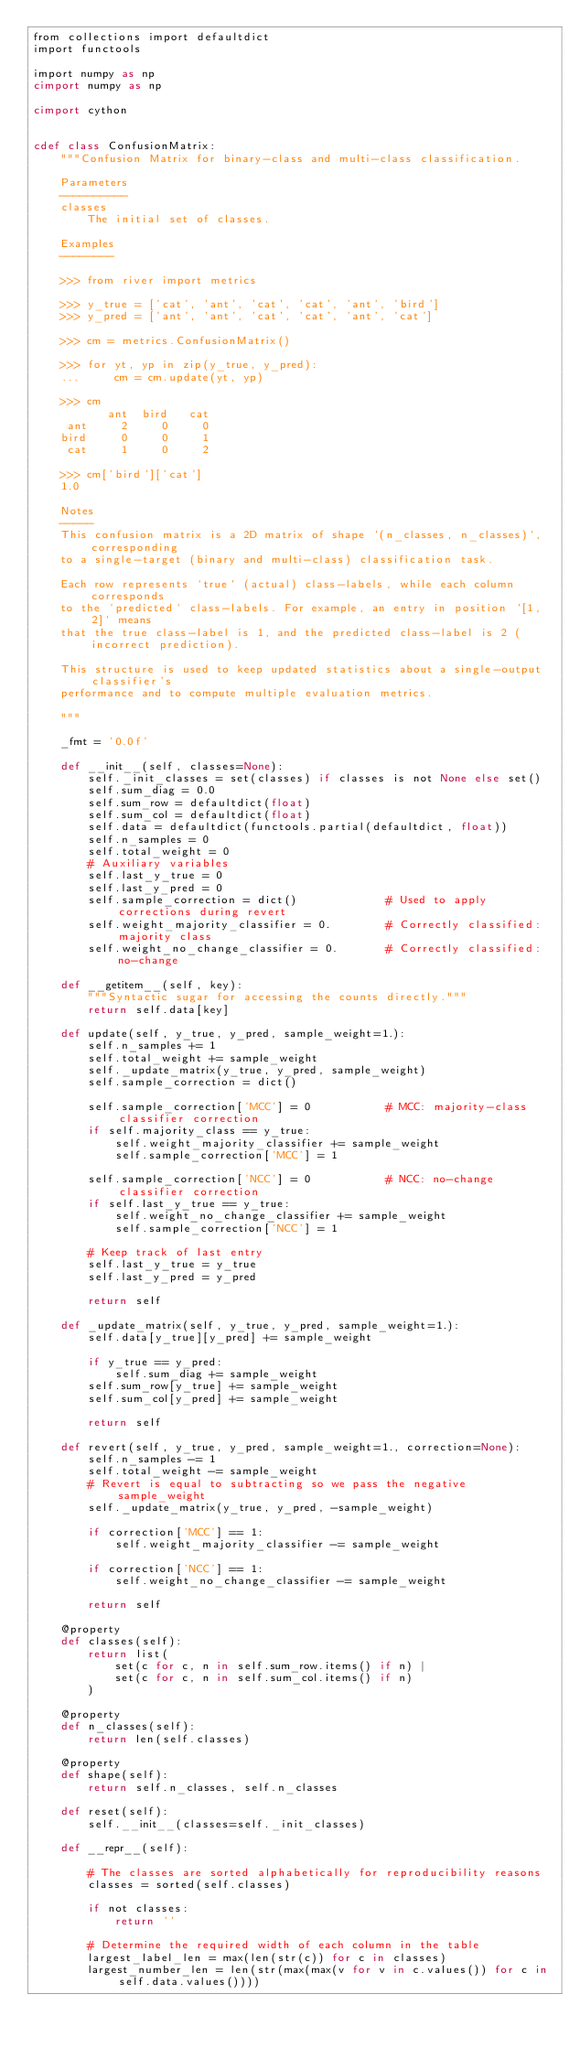<code> <loc_0><loc_0><loc_500><loc_500><_Cython_>from collections import defaultdict
import functools

import numpy as np
cimport numpy as np

cimport cython


cdef class ConfusionMatrix:
    """Confusion Matrix for binary-class and multi-class classification.

    Parameters
    ----------
    classes
        The initial set of classes.

    Examples
    --------

    >>> from river import metrics

    >>> y_true = ['cat', 'ant', 'cat', 'cat', 'ant', 'bird']
    >>> y_pred = ['ant', 'ant', 'cat', 'cat', 'ant', 'cat']

    >>> cm = metrics.ConfusionMatrix()

    >>> for yt, yp in zip(y_true, y_pred):
    ...     cm = cm.update(yt, yp)

    >>> cm
           ant  bird   cat
     ant     2     0     0
    bird     0     0     1
     cat     1     0     2

    >>> cm['bird']['cat']
    1.0

    Notes
    -----
    This confusion matrix is a 2D matrix of shape `(n_classes, n_classes)`, corresponding
    to a single-target (binary and multi-class) classification task.

    Each row represents `true` (actual) class-labels, while each column corresponds
    to the `predicted` class-labels. For example, an entry in position `[1, 2]` means
    that the true class-label is 1, and the predicted class-label is 2 (incorrect prediction).

    This structure is used to keep updated statistics about a single-output classifier's
    performance and to compute multiple evaluation metrics.

    """

    _fmt = '0.0f'

    def __init__(self, classes=None):
        self._init_classes = set(classes) if classes is not None else set()
        self.sum_diag = 0.0
        self.sum_row = defaultdict(float)
        self.sum_col = defaultdict(float)
        self.data = defaultdict(functools.partial(defaultdict, float))
        self.n_samples = 0
        self.total_weight = 0
        # Auxiliary variables
        self.last_y_true = 0
        self.last_y_pred = 0
        self.sample_correction = dict()             # Used to apply corrections during revert
        self.weight_majority_classifier = 0.        # Correctly classified: majority class
        self.weight_no_change_classifier = 0.       # Correctly classified: no-change

    def __getitem__(self, key):
        """Syntactic sugar for accessing the counts directly."""
        return self.data[key]

    def update(self, y_true, y_pred, sample_weight=1.):
        self.n_samples += 1
        self.total_weight += sample_weight
        self._update_matrix(y_true, y_pred, sample_weight)
        self.sample_correction = dict()

        self.sample_correction['MCC'] = 0           # MCC: majority-class classifier correction
        if self.majority_class == y_true:
            self.weight_majority_classifier += sample_weight
            self.sample_correction['MCC'] = 1

        self.sample_correction['NCC'] = 0           # NCC: no-change classifier correction
        if self.last_y_true == y_true:
            self.weight_no_change_classifier += sample_weight
            self.sample_correction['NCC'] = 1

        # Keep track of last entry
        self.last_y_true = y_true
        self.last_y_pred = y_pred

        return self

    def _update_matrix(self, y_true, y_pred, sample_weight=1.):
        self.data[y_true][y_pred] += sample_weight

        if y_true == y_pred:
            self.sum_diag += sample_weight
        self.sum_row[y_true] += sample_weight
        self.sum_col[y_pred] += sample_weight

        return self

    def revert(self, y_true, y_pred, sample_weight=1., correction=None):
        self.n_samples -= 1
        self.total_weight -= sample_weight
        # Revert is equal to subtracting so we pass the negative sample_weight
        self._update_matrix(y_true, y_pred, -sample_weight)

        if correction['MCC'] == 1:
            self.weight_majority_classifier -= sample_weight

        if correction['NCC'] == 1:
            self.weight_no_change_classifier -= sample_weight

        return self

    @property
    def classes(self):
        return list(
            set(c for c, n in self.sum_row.items() if n) |
            set(c for c, n in self.sum_col.items() if n)
        )

    @property
    def n_classes(self):
        return len(self.classes)

    @property
    def shape(self):
        return self.n_classes, self.n_classes

    def reset(self):
        self.__init__(classes=self._init_classes)

    def __repr__(self):

        # The classes are sorted alphabetically for reproducibility reasons
        classes = sorted(self.classes)

        if not classes:
            return ''

        # Determine the required width of each column in the table
        largest_label_len = max(len(str(c)) for c in classes)
        largest_number_len = len(str(max(max(v for v in c.values()) for c in self.data.values())))</code> 